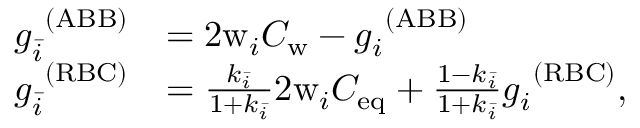<formula> <loc_0><loc_0><loc_500><loc_500>\begin{array} { r l } { g _ { \bar { i } } ^ { \ ( A B B ) } } & { = 2 w _ { i } C _ { w } - g _ { i } ^ { \ ( A B B ) } } \\ { g _ { \bar { i } } ^ { \ ( R B C ) } } & { = \frac { k _ { \bar { i } } } { 1 + k _ { \bar { i } } } 2 w _ { i } C _ { e q } + \frac { 1 - k _ { \bar { i } } } { 1 + k _ { \bar { i } } } g _ { i } ^ { \ ( R B C ) } , } \end{array}</formula> 